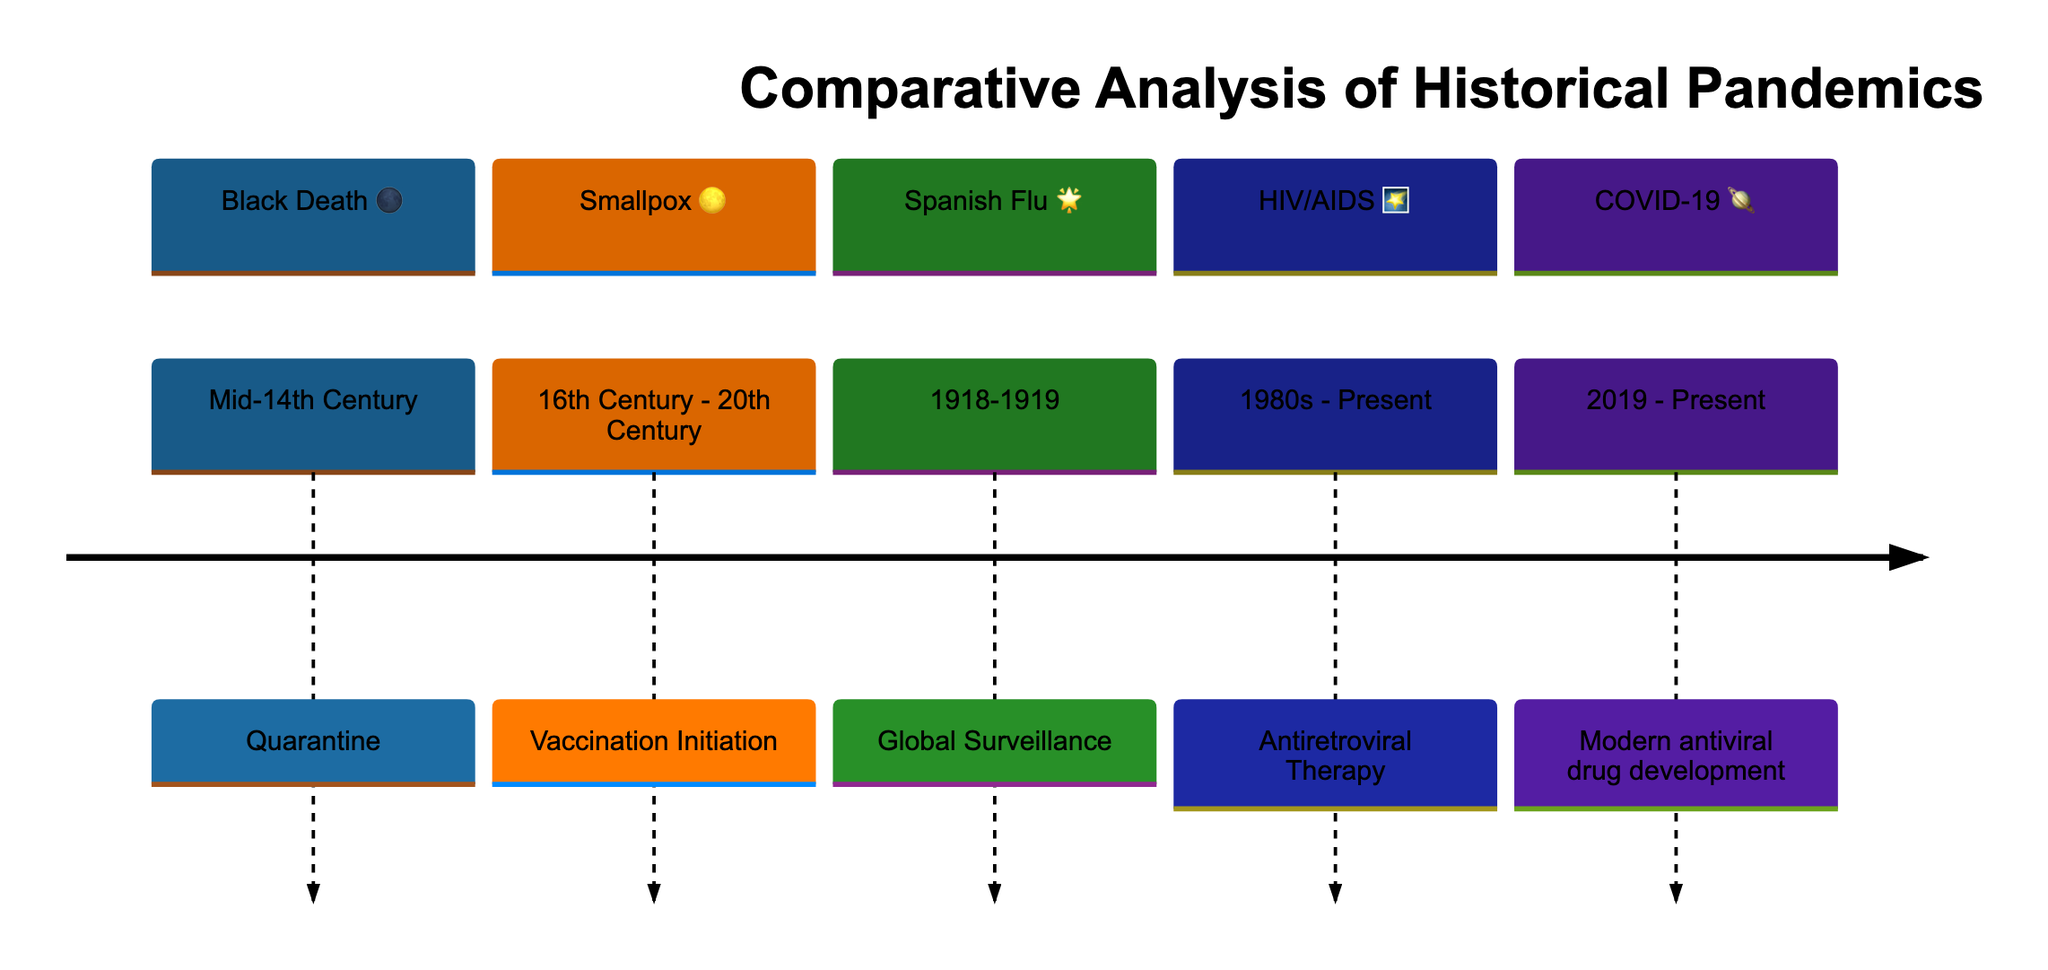What pandemic is associated with the quarantine measure? The diagram indicates that the Black Death is the pandemic associated with the quarantine measure in the mid-14th century. This is noted in the section of the diagram focusing on the Black Death.
Answer: Black Death How long did the vaccination initiation for smallpox occur? The diagram specifies that vaccination initiation for smallpox occurred from the 16th century to the 20th century, presenting this as a time span indicating several hundred years.
Answer: 16th Century - 20th Century What control measure is listed for the Spanish Flu? According to the diagram, the control measure listed for the Spanish Flu is global surveillance, which is noted in the section dedicated to it and spans the years 1918-1919.
Answer: Global Surveillance Which pandemic was introduced by the initiation of antiretroviral therapy? The diagram indicates that HIV/AIDS was introduced by the initiation of antiretroviral therapy, reflecting its importance in controlling the spread of the disease since the 1980s.
Answer: HIV/AIDS During which years is the COVID-19 section represented? The COVID-19 section of the diagram is represented from 2019 to the present, indicating the ongoing nature of the pandemic and recent developments in antiviral drug development.
Answer: 2019 - Present Why is the Black Death symbolized by a moon (🌑)? In this astronomical-themed timeline, the moon symbol typically represents the Black Death, possibly indicating the historical and ominous nature of this pandemic's impact on humanity in a figurative way.
Answer: The moon (🌑) What is the specific event associated with the pandemic represented by the star (🌟)? The star symbol (🌟) refers specifically to the Spanish Flu and is associated with the event of global surveillance, which is crucial for understanding how surveillance strategies evolved during that pandemic.
Answer: Global Surveillance How many main sections are presented in this diagram? The diagram distinctly has five main sections, with each section designated to a significant pandemic and its control measures, clearly illustrating the comparative analysis aspect of pandemics.
Answer: 5 Which key events are denoted by the symbols in the diagram? The diagram employs distinct symbols like the moon (🌑), the full moon (🌕), the star (🌟), the shooting star (🌠), and the planet (🪐) to denote key events in each pandemic's timeline, emphasizing their unique significance in history.
Answer: Key events are denoted by unique symbols 